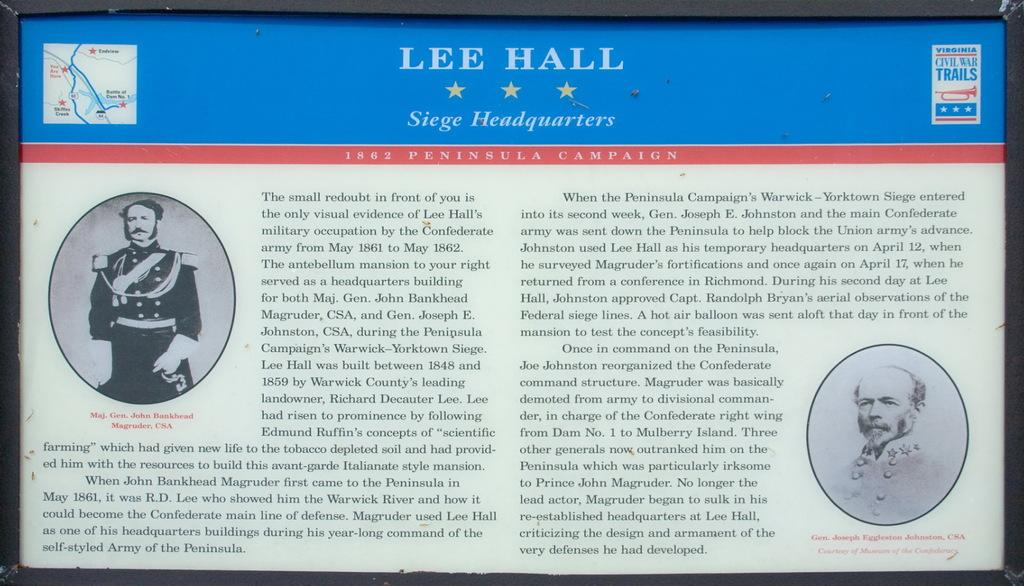What is the main subject of the image? The main subject of the image is a power point presentation. What text can be seen at the top of the presentation? The presentation has the text "LEE HALL" and "SERGE HEADWATERS" at the top. How many stars are present in the presentation? There are 3 stars in the presentation. What other elements are included in the presentation? There are pictures and text in the presentation. What type of leaf is depicted in the presentation? There is no leaf present in the image; it features a power point presentation with text and images related to "LEE HALL" and "SERGE HEADWATERS." 